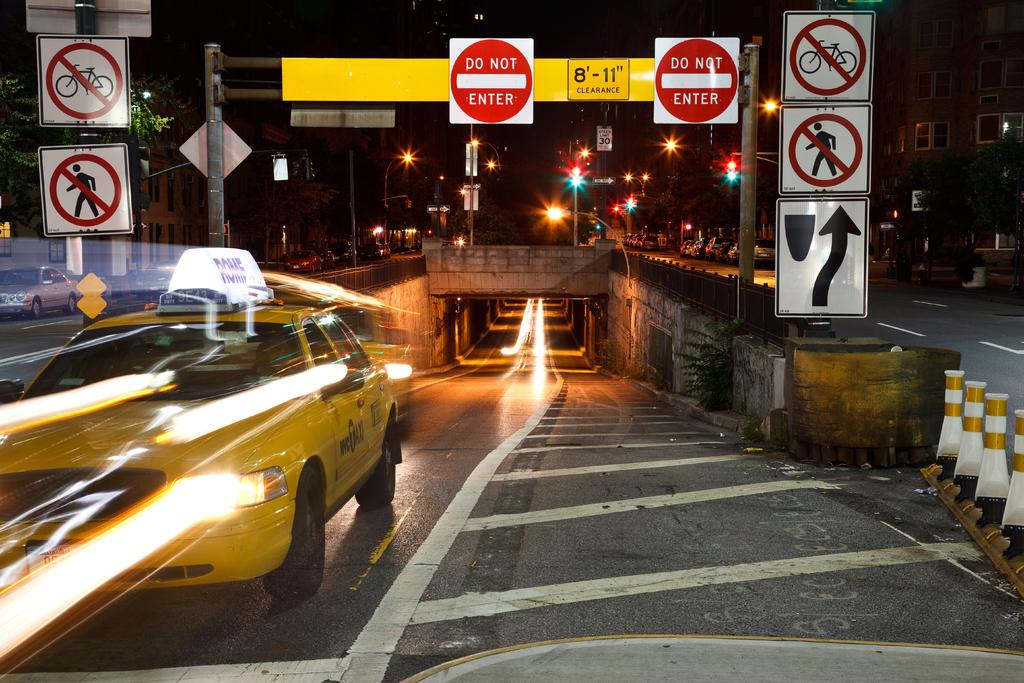<image>
Summarize the visual content of the image. Road signs with two of them being DO NOT ENTER signs. 